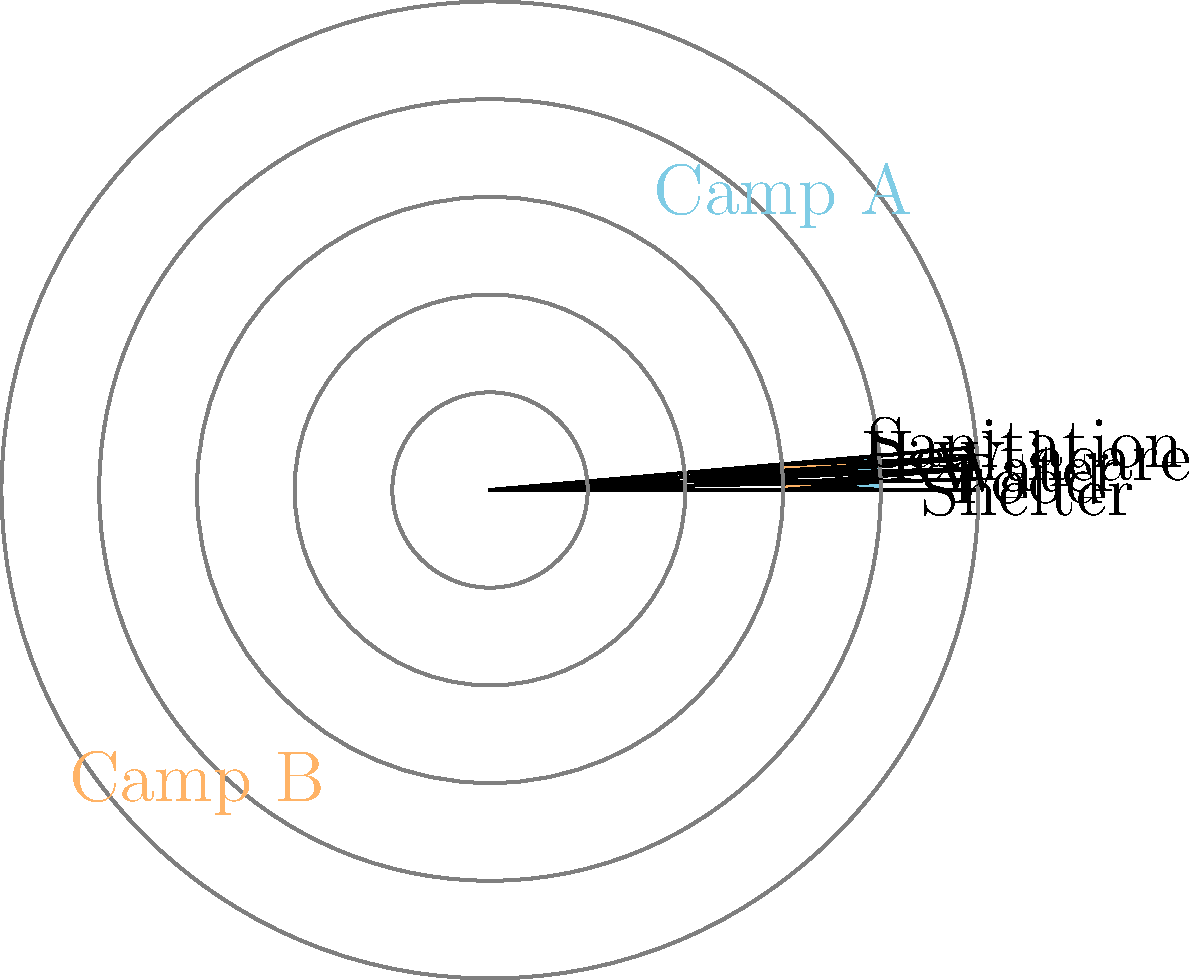Based on the radar chart comparing living conditions in two refugee camps, which camp appears to have better overall conditions, and what specific area shows the most significant difference between the two camps? To answer this question, we need to analyze the radar chart step-by-step:

1. The chart compares five categories: Shelter, Food, Water, Healthcare, and Sanitation for two camps (Camp A in blue and Camp B in orange).

2. For each category, a higher score (further from the center) indicates better conditions.

3. Let's compare the scores for each category:
   - Shelter: Camp A (4) > Camp B (3)
   - Food: Camp A (3) < Camp B (4)
   - Water: Camp A (5) > Camp B (2)
   - Healthcare: Camp A (2) < Camp B (5)
   - Sanitation: Camp A (4) > Camp B (3)

4. To determine overall better conditions, we can count how many categories each camp scores higher in:
   - Camp A scores higher in 3 categories (Shelter, Water, Sanitation)
   - Camp B scores higher in 2 categories (Food, Healthcare)

5. The most significant difference between the two camps can be found by calculating the largest gap in scores for each category:
   - Shelter: 4 - 3 = 1
   - Food: 4 - 3 = 1
   - Water: 5 - 2 = 3
   - Healthcare: 5 - 2 = 3
   - Sanitation: 4 - 3 = 1

The largest difference is 3, occurring in both Water (favoring Camp A) and Healthcare (favoring Camp B).
Answer: Camp A has better overall conditions. Water and Healthcare show the most significant differences. 